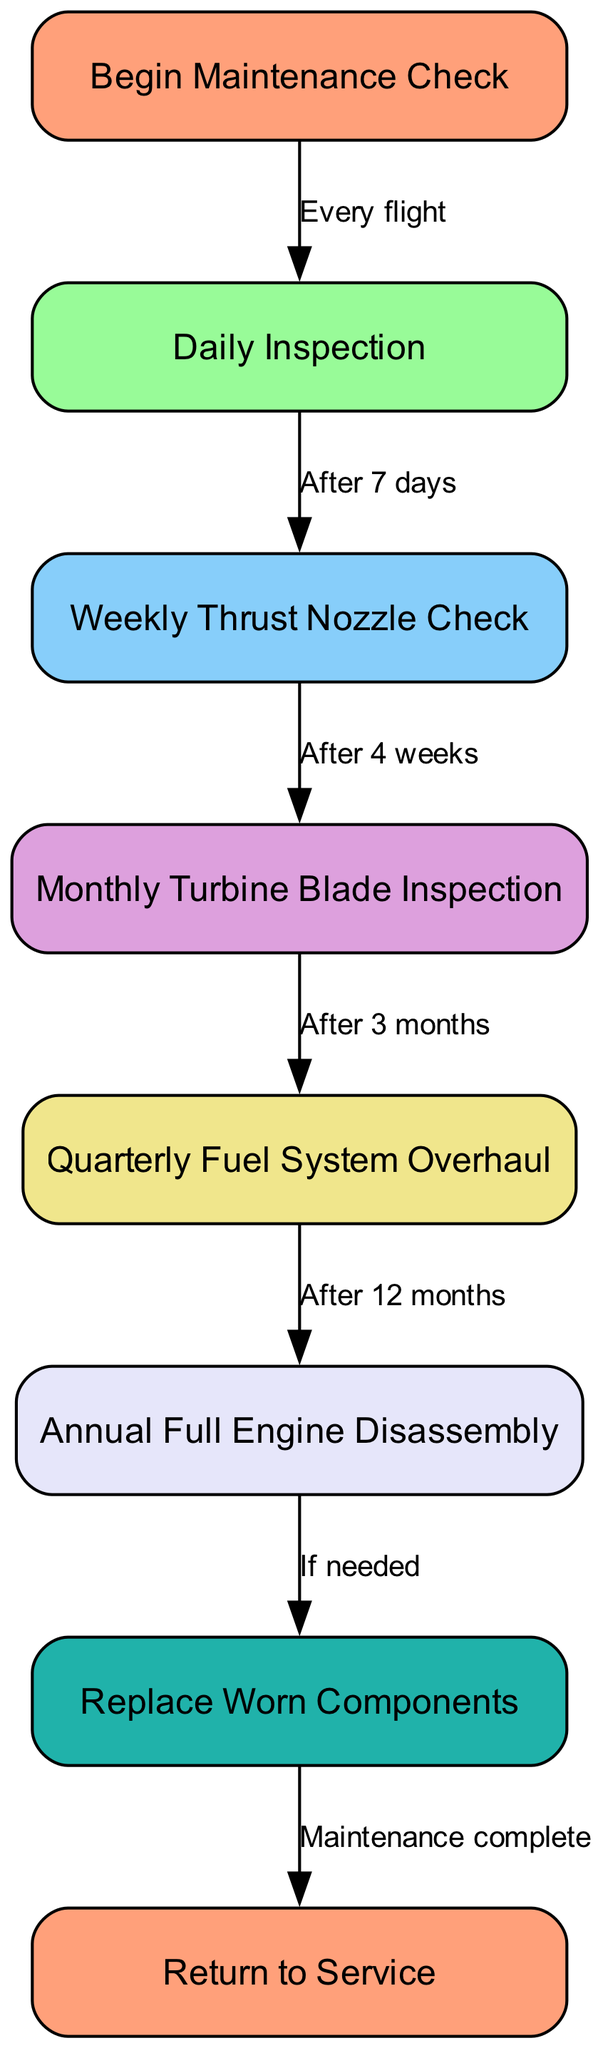What is the starting point of the maintenance schedule? The diagram begins with the node labeled "Begin Maintenance Check," which signifies the initiation of the maintenance process for the supersonic jet engine.
Answer: Begin Maintenance Check How many inspection nodes are there? The diagram contains five inspection nodes: Daily Inspection, Weekly Thrust Nozzle Check, Monthly Turbine Blade Inspection, Quarterly Fuel System Overhaul, and Annual Full Engine Disassembly. Thus, there are five inspection nodes.
Answer: 5 What happens after a daily inspection? After completing a Daily Inspection, the flowchart indicates that the next step is to conduct a Weekly Thrust Nozzle Check, as shown by the edge pointing to that node with the label "After 7 days."
Answer: Weekly Thrust Nozzle Check What is the condition for replacing worn components? The condition for replacing worn components occurs after the Annual Full Engine Disassembly, indicated by the edge labeled "If needed," which leads to the Replace Worn Components node.
Answer: If needed Which node follows the Quarterly Fuel System Overhaul? The next node that follows the Quarterly Fuel System Overhaul is the Annual Full Engine Disassembly, as directed by the edge connecting the two nodes and labeled "After 12 months."
Answer: Annual Full Engine Disassembly What is the total number of edges in the diagram? The diagram contains six edges that connect various nodes, detailing the relationships and transitions between the maintenance steps. The edges represent the flow and timing of the maintenance checks.
Answer: 6 What is the final step in the maintenance process? The final step in the maintenance process is labeled "Return to Service," and it follows the node where worn components are replaced, marking the completion of the maintenance schedule.
Answer: Return to Service Which inspection cycle comes after the Monthly Turbine Blade Inspection? After the Monthly Turbine Blade Inspection, the next inspection cycle is the Quarterly Fuel System Overhaul, as represented by the edge labeled "After 3 months."
Answer: Quarterly Fuel System Overhaul Name the node that indicates a daily check is required. The node that indicates a daily check is required is the Daily Inspection, where maintenance begins after every flight of the supersonic jet.
Answer: Daily Inspection 